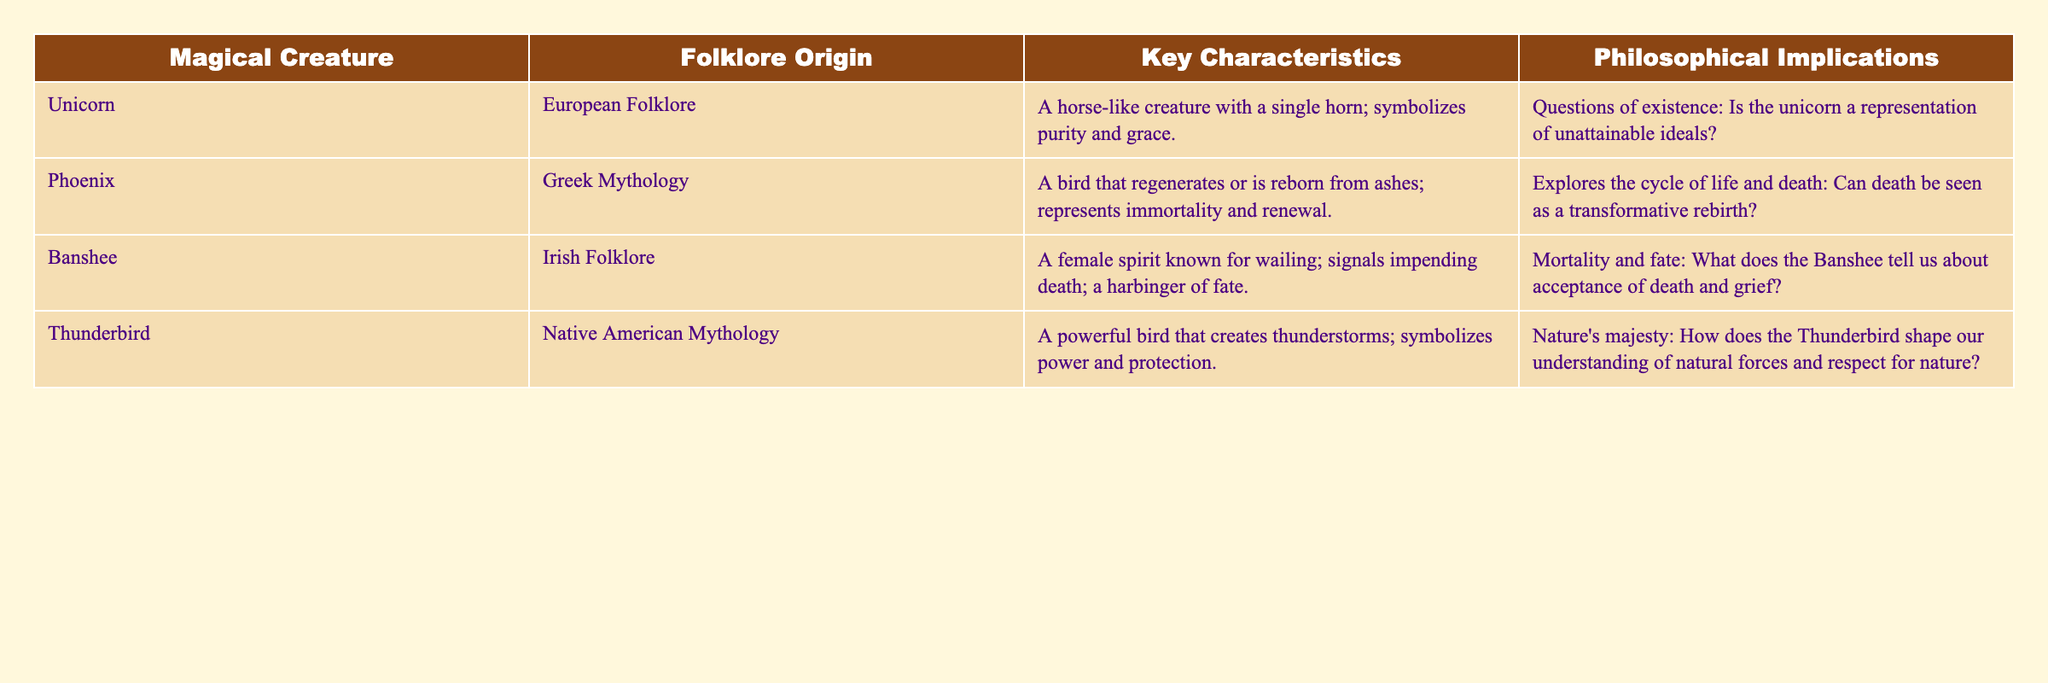What is the folklore origin of the Phoenix? The table directly lists the folklore origin of the Phoenix under the "Folklore Origin" column, indicating it is from "Greek Mythology."
Answer: Greek Mythology What key characteristic does the Banshee have? The table specifies under the "Key Characteristics" column that the Banshee is known for wailing and signaling impending death.
Answer: Wailing and signaling impending death What is the philosophical implication associated with the Unicorn? By referring to the "Philosophical Implications" column, the Unicorn relates to questions about existence and unattainable ideals.
Answer: Questions of existence related to unattainable ideals How many magical creatures in folklore are mentioned in the table? The table lists four magical creatures, including the Unicorn, Phoenix, Banshee, and Thunderbird. This can be counted directly.
Answer: Four Is the Thunderbirds' folklore origin Native American? By checking the "Folklore Origin" of the Thunderbird in the table, it confirms that it originates from Native American Mythology.
Answer: Yes Identify which magical creature symbolizes both power and protection. The table indicates that the Thunderbird is characterized as a powerful bird that creates thunderstorms and symbolizes power and protection.
Answer: Thunderbird What are the key characteristics of the Phoenix, and how do they relate to life and death? The "Key Characteristics" of the Phoenix are its ability to regenerate or be reborn from ashes, which illustrates the philosophical implication of exploring the cycle of life and death as a transformative rebirth.
Answer: Regenerates from ashes, related to life and death cycle Which creature represents the themes of mortality and fate, according to the table? The table specifies that the Banshee symbolizes mortality and fate, signaling impending death. This can be found under the respective entries for the Banshee.
Answer: Banshee Does the table suggest that all magical creatures have unique philosophical implications? By analyzing the "Philosophical Implications" column, each creature has a distinct implication tied to its characteristics and folklore origin. Therefore, yes, they all have unique implications.
Answer: Yes Can one infer a relationship between the Unicorn's symbolism of purity and its philosophical implications? The table suggests that the Unicorn's symbolism of purity connects to philosophical questions about existence and ideals, leading to the inference that there is a relationship between its symbolism and implications.
Answer: Yes, there is a relationship 